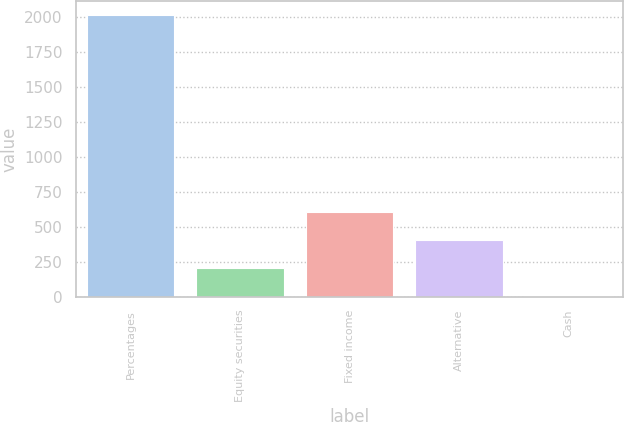Convert chart to OTSL. <chart><loc_0><loc_0><loc_500><loc_500><bar_chart><fcel>Percentages<fcel>Equity securities<fcel>Fixed income<fcel>Alternative<fcel>Cash<nl><fcel>2015<fcel>205.1<fcel>607.3<fcel>406.2<fcel>4<nl></chart> 